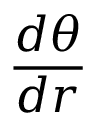Convert formula to latex. <formula><loc_0><loc_0><loc_500><loc_500>{ \frac { d \theta } { d r } }</formula> 